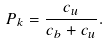Convert formula to latex. <formula><loc_0><loc_0><loc_500><loc_500>P _ { k } = \frac { c _ { u } } { c _ { b } + c _ { u } } .</formula> 